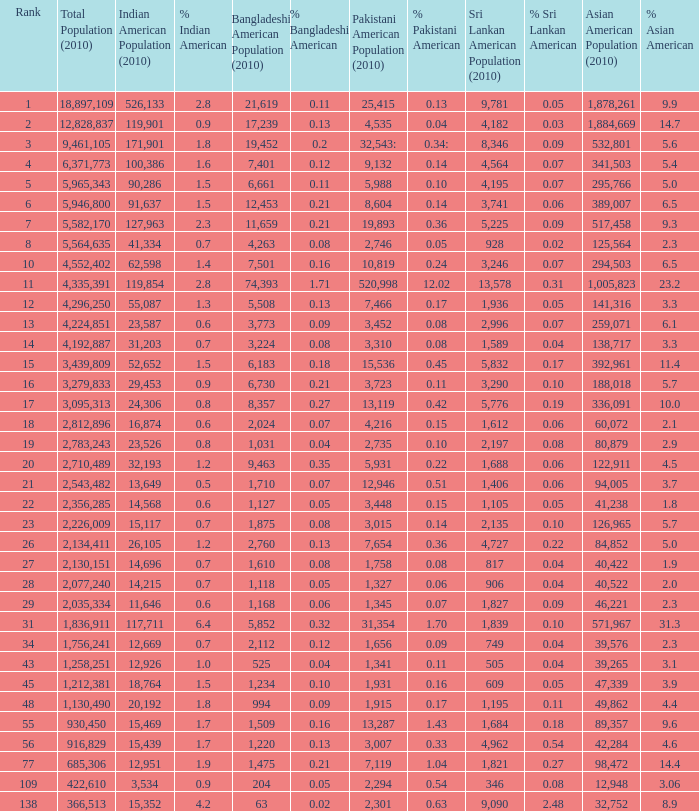What's the total population when the Asian American population is less than 60,072, the Indian American population is more than 14,696 and is 4.2% Indian American? 366513.0. Give me the full table as a dictionary. {'header': ['Rank', 'Total Population (2010)', 'Indian American Population (2010)', '% Indian American', 'Bangladeshi American Population (2010)', '% Bangladeshi American', 'Pakistani American Population (2010)', '% Pakistani American', 'Sri Lankan American Population (2010)', '% Sri Lankan American', 'Asian American Population (2010)', '% Asian American'], 'rows': [['1', '18,897,109', '526,133', '2.8', '21,619', '0.11', '25,415', '0.13', '9,781', '0.05', '1,878,261', '9.9'], ['2', '12,828,837', '119,901', '0.9', '17,239', '0.13', '4,535', '0.04', '4,182', '0.03', '1,884,669', '14.7'], ['3', '9,461,105', '171,901', '1.8', '19,452', '0.2', '32,543:', '0.34:', '8,346', '0.09', '532,801', '5.6'], ['4', '6,371,773', '100,386', '1.6', '7,401', '0.12', '9,132', '0.14', '4,564', '0.07', '341,503', '5.4'], ['5', '5,965,343', '90,286', '1.5', '6,661', '0.11', '5,988', '0.10', '4,195', '0.07', '295,766', '5.0'], ['6', '5,946,800', '91,637', '1.5', '12,453', '0.21', '8,604', '0.14', '3,741', '0.06', '389,007', '6.5'], ['7', '5,582,170', '127,963', '2.3', '11,659', '0.21', '19,893', '0.36', '5,225', '0.09', '517,458', '9.3'], ['8', '5,564,635', '41,334', '0.7', '4,263', '0.08', '2,746', '0.05', '928', '0.02', '125,564', '2.3'], ['10', '4,552,402', '62,598', '1.4', '7,501', '0.16', '10,819', '0.24', '3,246', '0.07', '294,503', '6.5'], ['11', '4,335,391', '119,854', '2.8', '74,393', '1.71', '520,998', '12.02', '13,578', '0.31', '1,005,823', '23.2'], ['12', '4,296,250', '55,087', '1.3', '5,508', '0.13', '7,466', '0.17', '1,936', '0.05', '141,316', '3.3'], ['13', '4,224,851', '23,587', '0.6', '3,773', '0.09', '3,452', '0.08', '2,996', '0.07', '259,071', '6.1'], ['14', '4,192,887', '31,203', '0.7', '3,224', '0.08', '3,310', '0.08', '1,589', '0.04', '138,717', '3.3'], ['15', '3,439,809', '52,652', '1.5', '6,183', '0.18', '15,536', '0.45', '5,832', '0.17', '392,961', '11.4'], ['16', '3,279,833', '29,453', '0.9', '6,730', '0.21', '3,723', '0.11', '3,290', '0.10', '188,018', '5.7'], ['17', '3,095,313', '24,306', '0.8', '8,357', '0.27', '13,119', '0.42', '5,776', '0.19', '336,091', '10.0'], ['18', '2,812,896', '16,874', '0.6', '2,024', '0.07', '4,216', '0.15', '1,612', '0.06', '60,072', '2.1'], ['19', '2,783,243', '23,526', '0.8', '1,031', '0.04', '2,735', '0.10', '2,197', '0.08', '80,879', '2.9'], ['20', '2,710,489', '32,193', '1.2', '9,463', '0.35', '5,931', '0.22', '1,688', '0.06', '122,911', '4.5'], ['21', '2,543,482', '13,649', '0.5', '1,710', '0.07', '12,946', '0.51', '1,406', '0.06', '94,005', '3.7'], ['22', '2,356,285', '14,568', '0.6', '1,127', '0.05', '3,448', '0.15', '1,105', '0.05', '41,238', '1.8'], ['23', '2,226,009', '15,117', '0.7', '1,875', '0.08', '3,015', '0.14', '2,135', '0.10', '126,965', '5.7'], ['26', '2,134,411', '26,105', '1.2', '2,760', '0.13', '7,654', '0.36', '4,727', '0.22', '84,852', '5.0'], ['27', '2,130,151', '14,696', '0.7', '1,610', '0.08', '1,758', '0.08', '817', '0.04', '40,422', '1.9'], ['28', '2,077,240', '14,215', '0.7', '1,118', '0.05', '1,327', '0.06', '906', '0.04', '40,522', '2.0'], ['29', '2,035,334', '11,646', '0.6', '1,168', '0.06', '1,345', '0.07', '1,827', '0.09', '46,221', '2.3'], ['31', '1,836,911', '117,711', '6.4', '5,852', '0.32', '31,354', '1.70', '1,839', '0.10', '571,967', '31.3'], ['34', '1,756,241', '12,669', '0.7', '2,112', '0.12', '1,656', '0.09', '749', '0.04', '39,576', '2.3'], ['43', '1,258,251', '12,926', '1.0', '525', '0.04', '1,341', '0.11', '505', '0.04', '39,265', '3.1'], ['45', '1,212,381', '18,764', '1.5', '1,234', '0.10', '1,931', '0.16', '609', '0.05', '47,339', '3.9'], ['48', '1,130,490', '20,192', '1.8', '994', '0.09', '1,915', '0.17', '1,195', '0.11', '49,862', '4.4'], ['55', '930,450', '15,469', '1.7', '1,509', '0.16', '13,287', '1.43', '1,684', '0.18', '89,357', '9.6'], ['56', '916,829', '15,439', '1.7', '1,220', '0.13', '3,007', '0.33', '4,962', '0.54', '42,284', '4.6'], ['77', '685,306', '12,951', '1.9', '1,475', '0.21', '7,119', '1.04', '1,821', '0.27', '98,472', '14.4'], ['109', '422,610', '3,534', '0.9', '204', '0.05', '2,294', '0.54', '346', '0.08', '12,948', '3.06'], ['138', '366,513', '15,352', '4.2', '63', '0.02', '2,301', '0.63', '9,090', '2.48', '32,752', '8.9']]} 